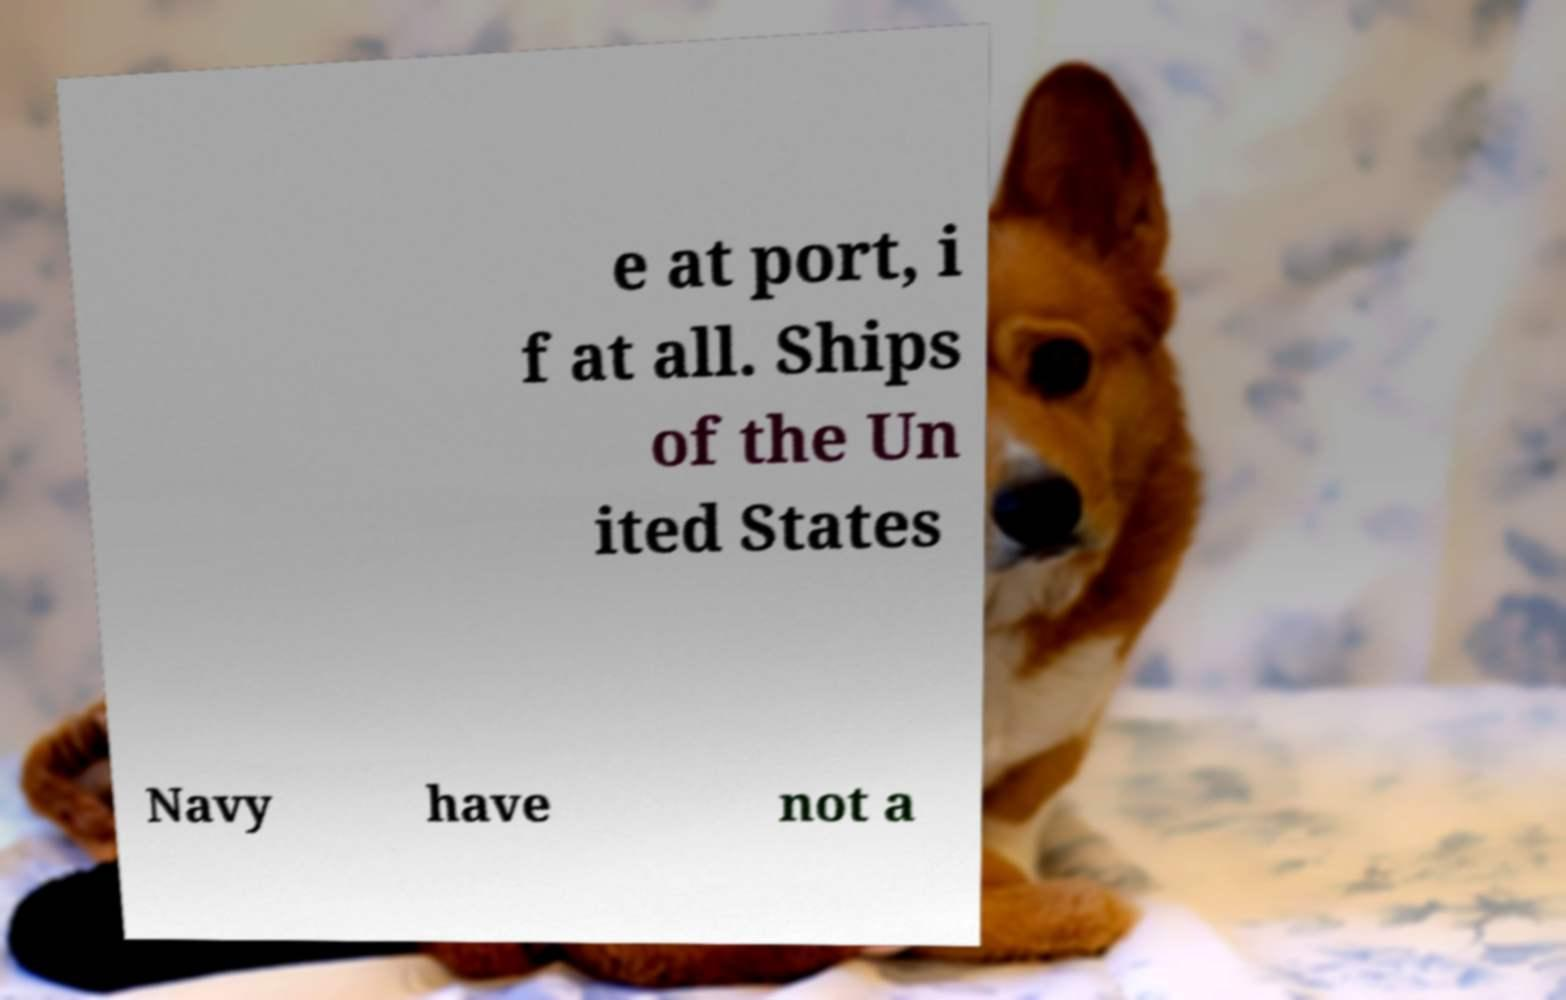Can you read and provide the text displayed in the image?This photo seems to have some interesting text. Can you extract and type it out for me? e at port, i f at all. Ships of the Un ited States Navy have not a 